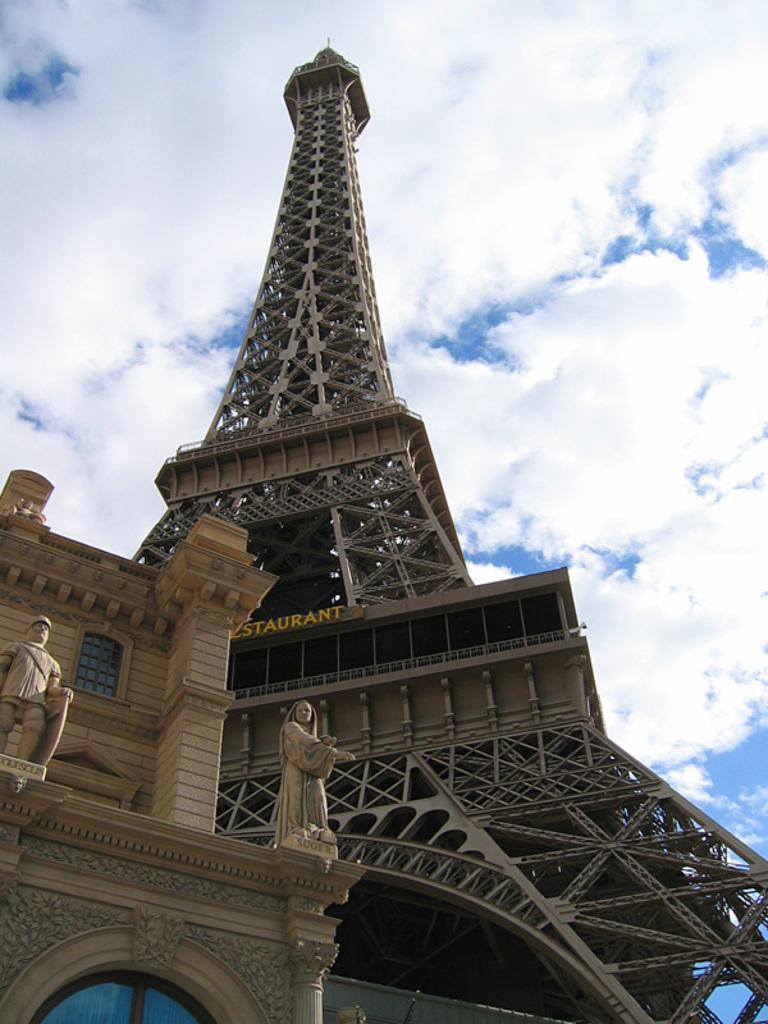How would you summarize this image in a sentence or two? In the center of the image there is an eiffel tower. On the left side of the image we can see building. In the background there are clouds and sky. 